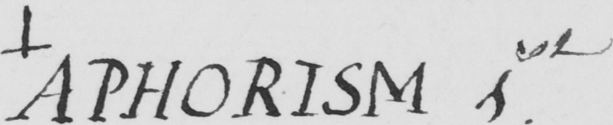What is written in this line of handwriting? + APHORISM 1st 